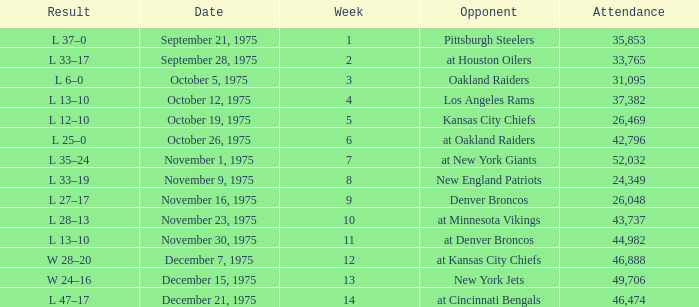What is the average Week when the result was w 28–20, and there were more than 46,888 in attendance? None. 